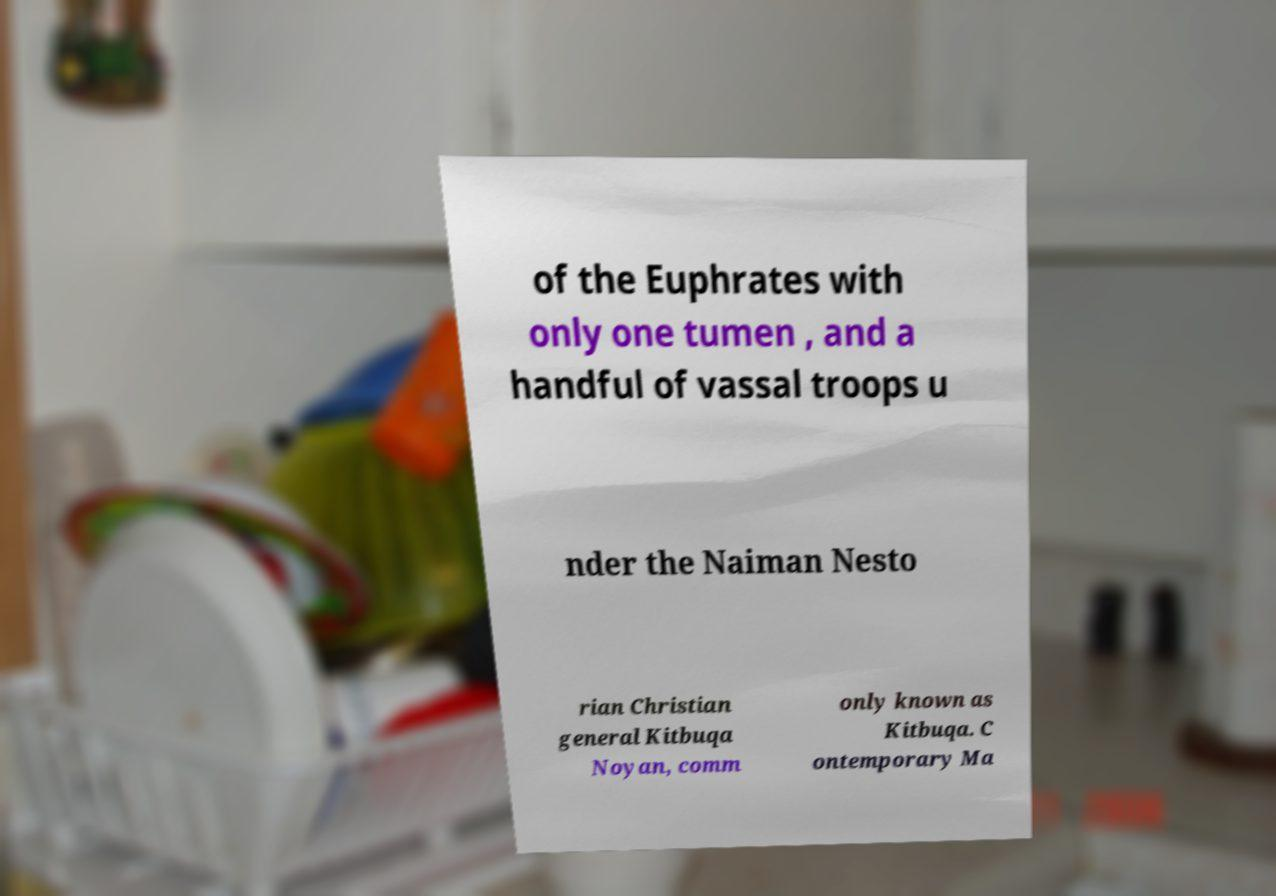Please identify and transcribe the text found in this image. of the Euphrates with only one tumen , and a handful of vassal troops u nder the Naiman Nesto rian Christian general Kitbuqa Noyan, comm only known as Kitbuqa. C ontemporary Ma 